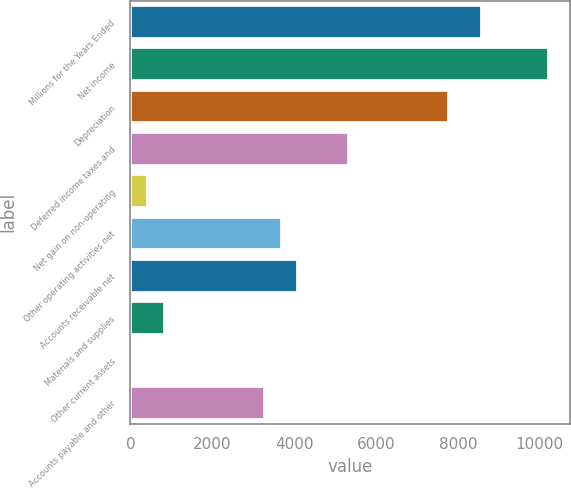Convert chart to OTSL. <chart><loc_0><loc_0><loc_500><loc_500><bar_chart><fcel>Millions for the Years Ended<fcel>Net income<fcel>Depreciation<fcel>Deferred income taxes and<fcel>Net gain on non-operating<fcel>Other operating activities net<fcel>Accounts receivable net<fcel>Materials and supplies<fcel>Other current assets<fcel>Accounts payable and other<nl><fcel>8601.8<fcel>10237<fcel>7784.2<fcel>5331.4<fcel>425.8<fcel>3696.2<fcel>4105<fcel>834.6<fcel>17<fcel>3287.4<nl></chart> 